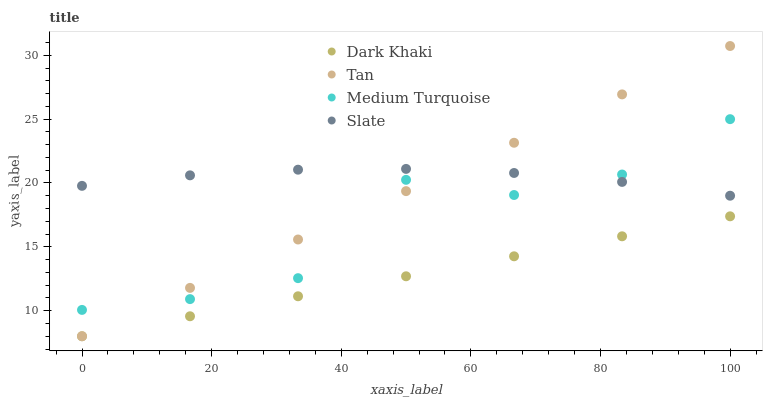Does Dark Khaki have the minimum area under the curve?
Answer yes or no. Yes. Does Slate have the maximum area under the curve?
Answer yes or no. Yes. Does Tan have the minimum area under the curve?
Answer yes or no. No. Does Tan have the maximum area under the curve?
Answer yes or no. No. Is Dark Khaki the smoothest?
Answer yes or no. Yes. Is Medium Turquoise the roughest?
Answer yes or no. Yes. Is Tan the smoothest?
Answer yes or no. No. Is Tan the roughest?
Answer yes or no. No. Does Dark Khaki have the lowest value?
Answer yes or no. Yes. Does Slate have the lowest value?
Answer yes or no. No. Does Tan have the highest value?
Answer yes or no. Yes. Does Slate have the highest value?
Answer yes or no. No. Is Dark Khaki less than Slate?
Answer yes or no. Yes. Is Slate greater than Dark Khaki?
Answer yes or no. Yes. Does Medium Turquoise intersect Tan?
Answer yes or no. Yes. Is Medium Turquoise less than Tan?
Answer yes or no. No. Is Medium Turquoise greater than Tan?
Answer yes or no. No. Does Dark Khaki intersect Slate?
Answer yes or no. No. 